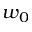Convert formula to latex. <formula><loc_0><loc_0><loc_500><loc_500>w _ { 0 }</formula> 